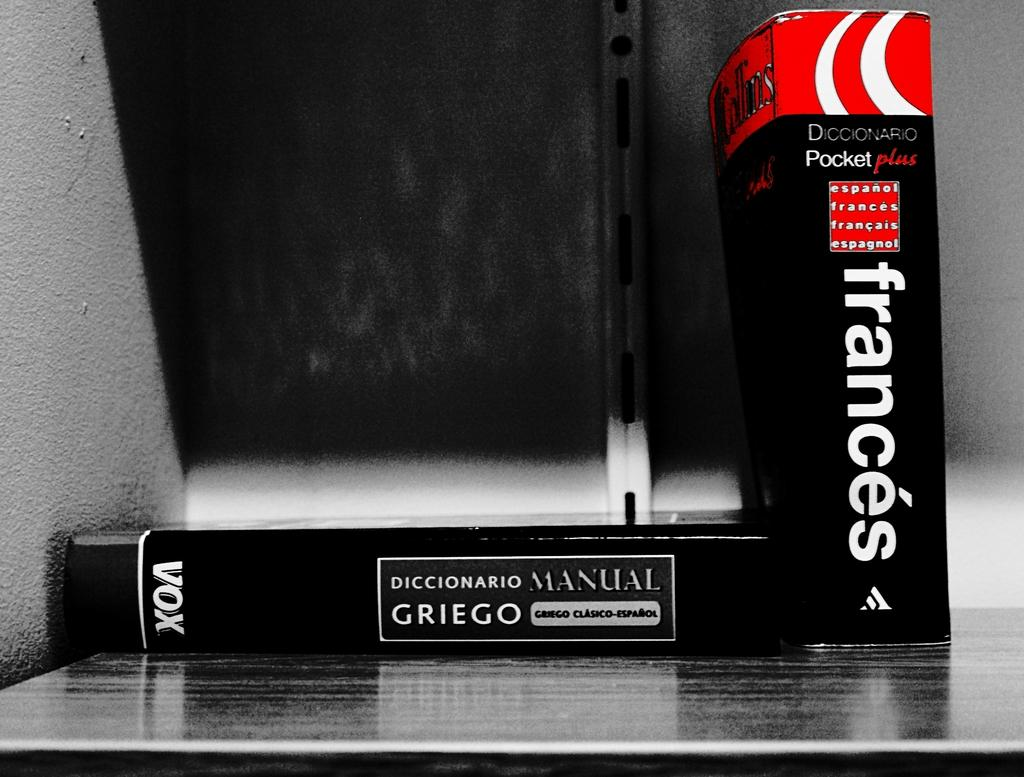Provide a one-sentence caption for the provided image. The book and dictionary manual are both written in French. 